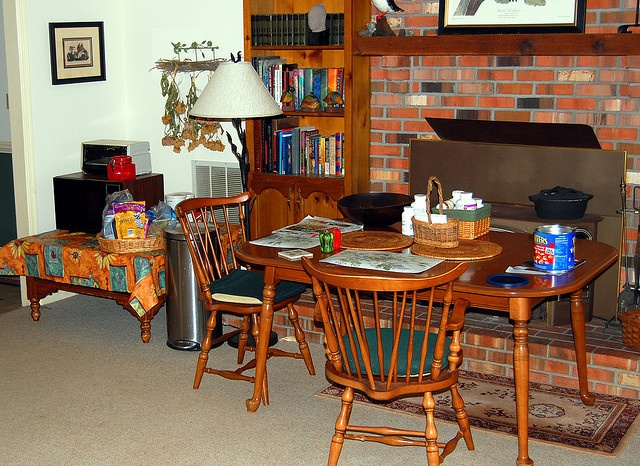Describe the objects in this image and their specific colors. I can see dining table in darkgray, maroon, brown, and black tones, chair in darkgray, maroon, brown, and red tones, chair in darkgray, black, maroon, and brown tones, book in darkgray, black, maroon, gray, and navy tones, and microwave in darkgray, black, gray, maroon, and ivory tones in this image. 